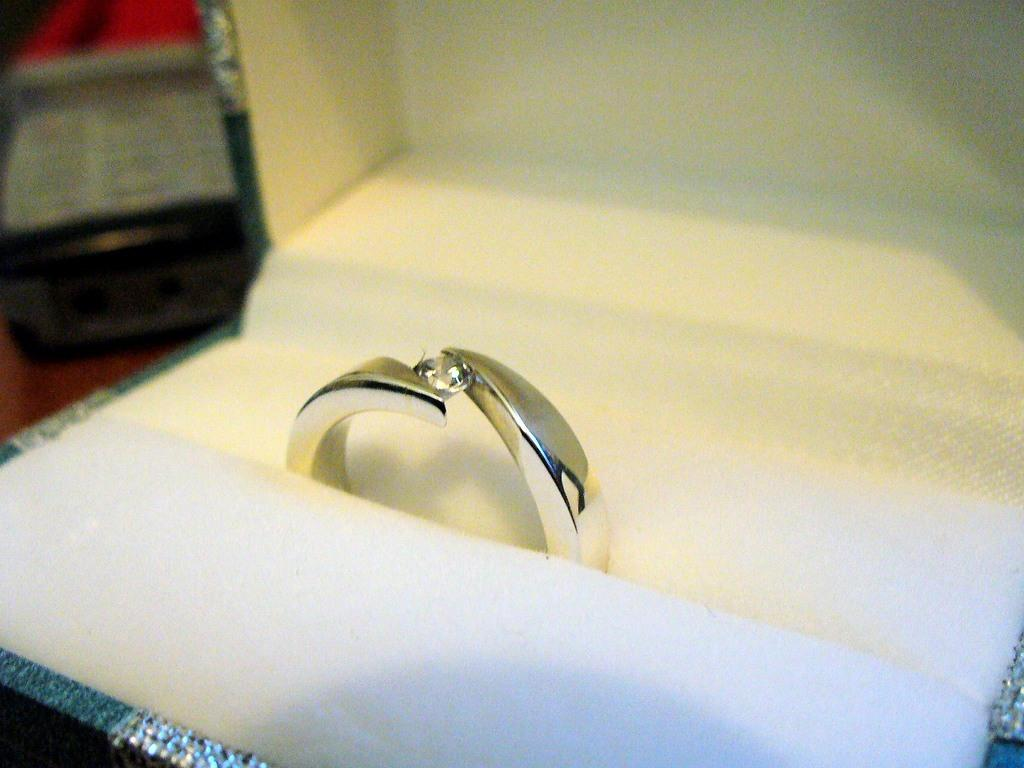What is the main subject of the image? The main subject of the image is a ring. Can you describe the background of the image? The background of the image is blurry. What type of pear is growing on the plant in the image? There is no pear or plant present in the image; it only features a ring with a blurry background. 